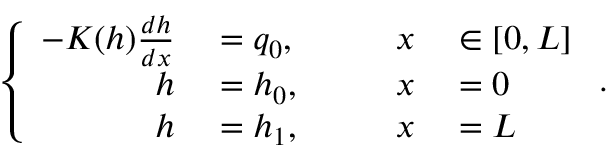<formula> <loc_0><loc_0><loc_500><loc_500>\left \{ \begin{array} { r l r l } { - K ( h ) \frac { d h } { d x } } & = q _ { 0 } , \quad } & { x } & \in [ 0 , L ] } \\ { h } & = h _ { 0 } , } & { x } & = 0 } \\ { h } & = h _ { 1 } , } & { x } & = L } \end{array} .</formula> 